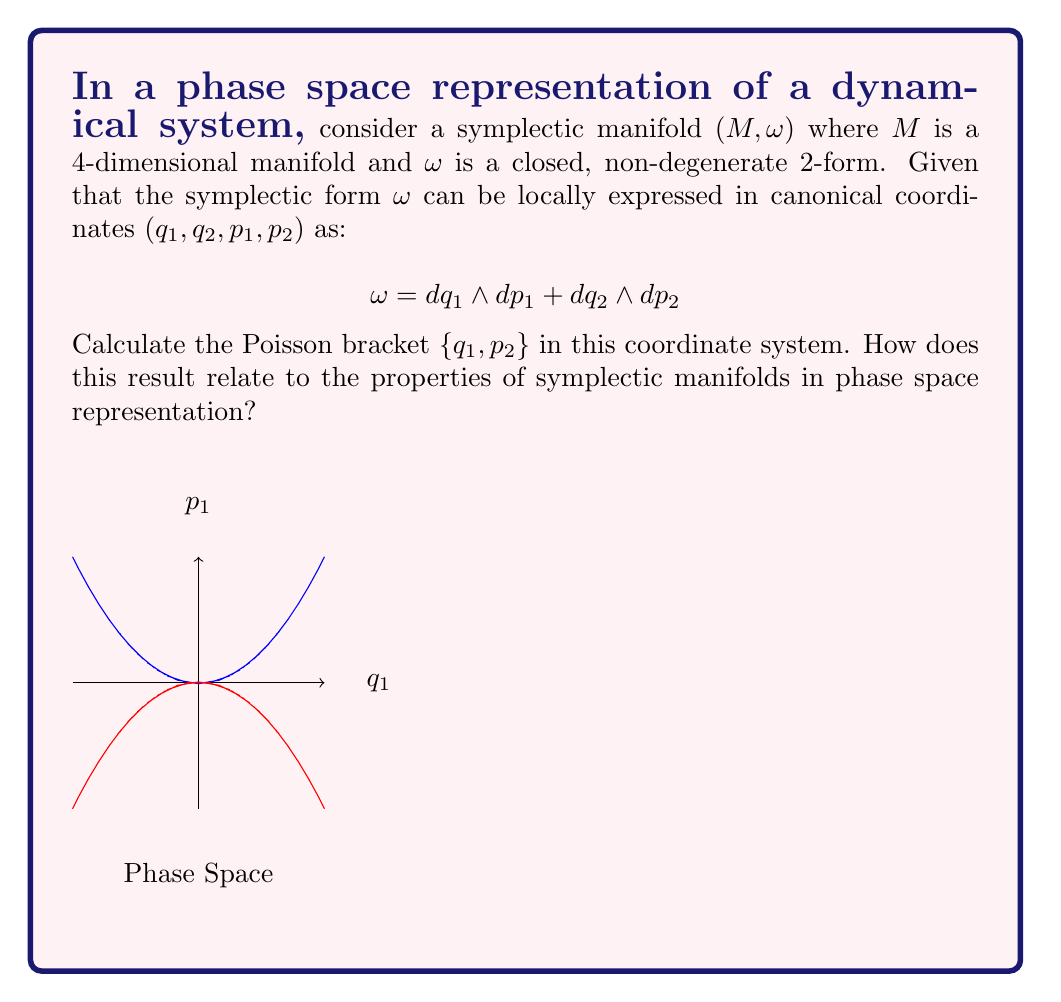Can you answer this question? Let's approach this step-by-step:

1) In a symplectic manifold, the Poisson bracket of two functions $f$ and $g$ is defined using the symplectic form $\omega$:

   $$\{f,g\} = \omega(X_f, X_g)$$

   where $X_f$ and $X_g$ are the Hamiltonian vector fields corresponding to $f$ and $g$.

2) In canonical coordinates $(q_1, q_2, p_1, p_2)$, the Poisson bracket has a specific form:

   $$\{f,g\} = \sum_{i=1}^n \left(\frac{\partial f}{\partial q_i}\frac{\partial g}{\partial p_i} - \frac{\partial f}{\partial p_i}\frac{\partial g}{\partial q_i}\right)$$

   where $n$ is half the dimension of the manifold (in this case, $n=2$).

3) For our question, we need to calculate $\{q_1, p_2\}$. Let $f=q_1$ and $g=p_2$.

4) Calculating the partial derivatives:
   
   $\frac{\partial f}{\partial q_1} = 1$, $\frac{\partial f}{\partial q_2} = 0$
   $\frac{\partial f}{\partial p_1} = 0$, $\frac{\partial f}{\partial p_2} = 0$
   
   $\frac{\partial g}{\partial q_1} = 0$, $\frac{\partial g}{\partial q_2} = 0$
   $\frac{\partial g}{\partial p_1} = 0$, $\frac{\partial g}{\partial p_2} = 1$

5) Plugging into the Poisson bracket formula:

   $$\{q_1, p_2\} = (1 \cdot 0 - 0 \cdot 0) + (0 \cdot 1 - 0 \cdot 0) = 0$$

6) This result relates to key properties of symplectic manifolds in phase space:

   a) It demonstrates the canonical commutation relations, where coordinates and momenta in different dimensions commute.
   
   b) It preserves the symplectic structure, which is crucial for describing Hamiltonian systems in phase space.
   
   c) It reflects the duality between position and momentum variables in conjugate pairs, which is a fundamental aspect of symplectic geometry in phase space representations.
Answer: $\{q_1, p_2\} = 0$ 